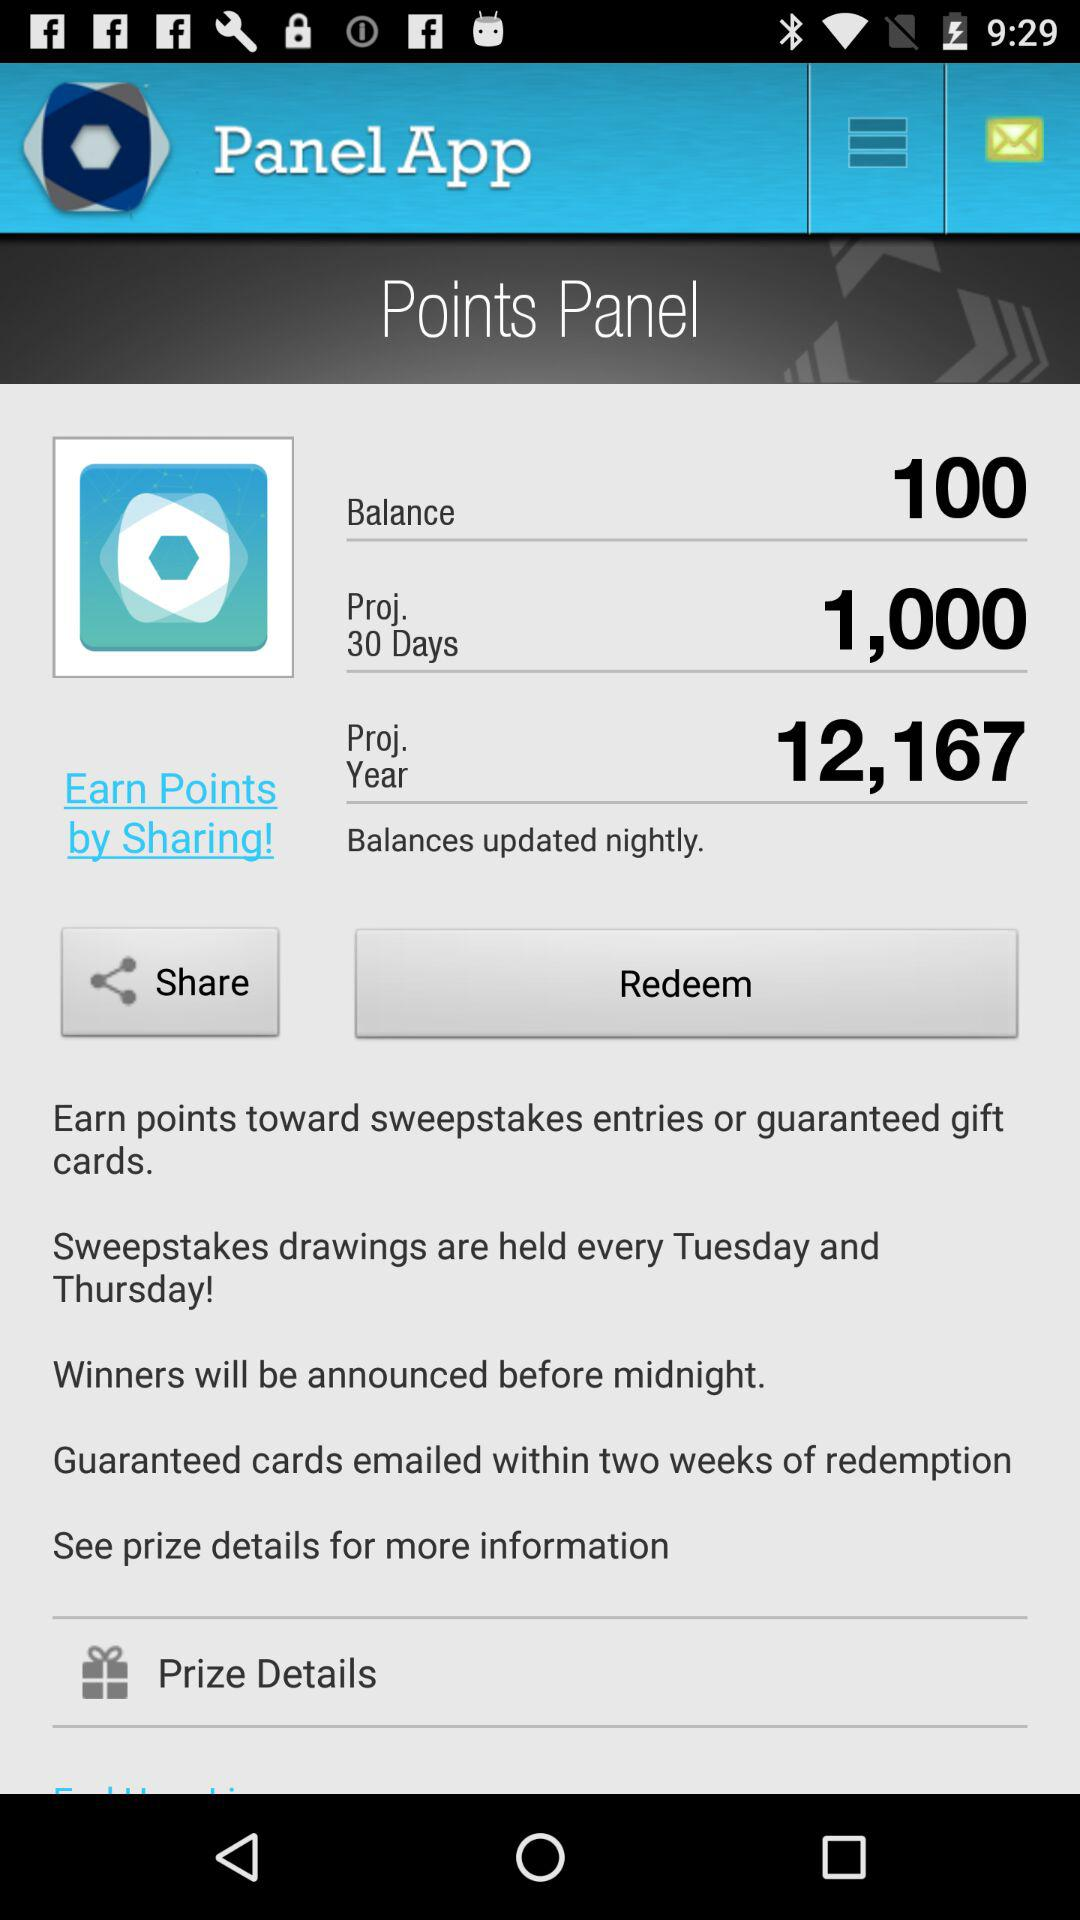How much is the balance? The balance is 100. 